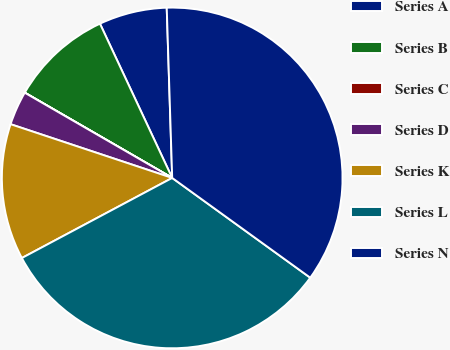Convert chart to OTSL. <chart><loc_0><loc_0><loc_500><loc_500><pie_chart><fcel>Series A<fcel>Series B<fcel>Series C<fcel>Series D<fcel>Series K<fcel>Series L<fcel>Series N<nl><fcel>6.46%<fcel>9.68%<fcel>0.01%<fcel>3.23%<fcel>12.9%<fcel>32.25%<fcel>35.47%<nl></chart> 